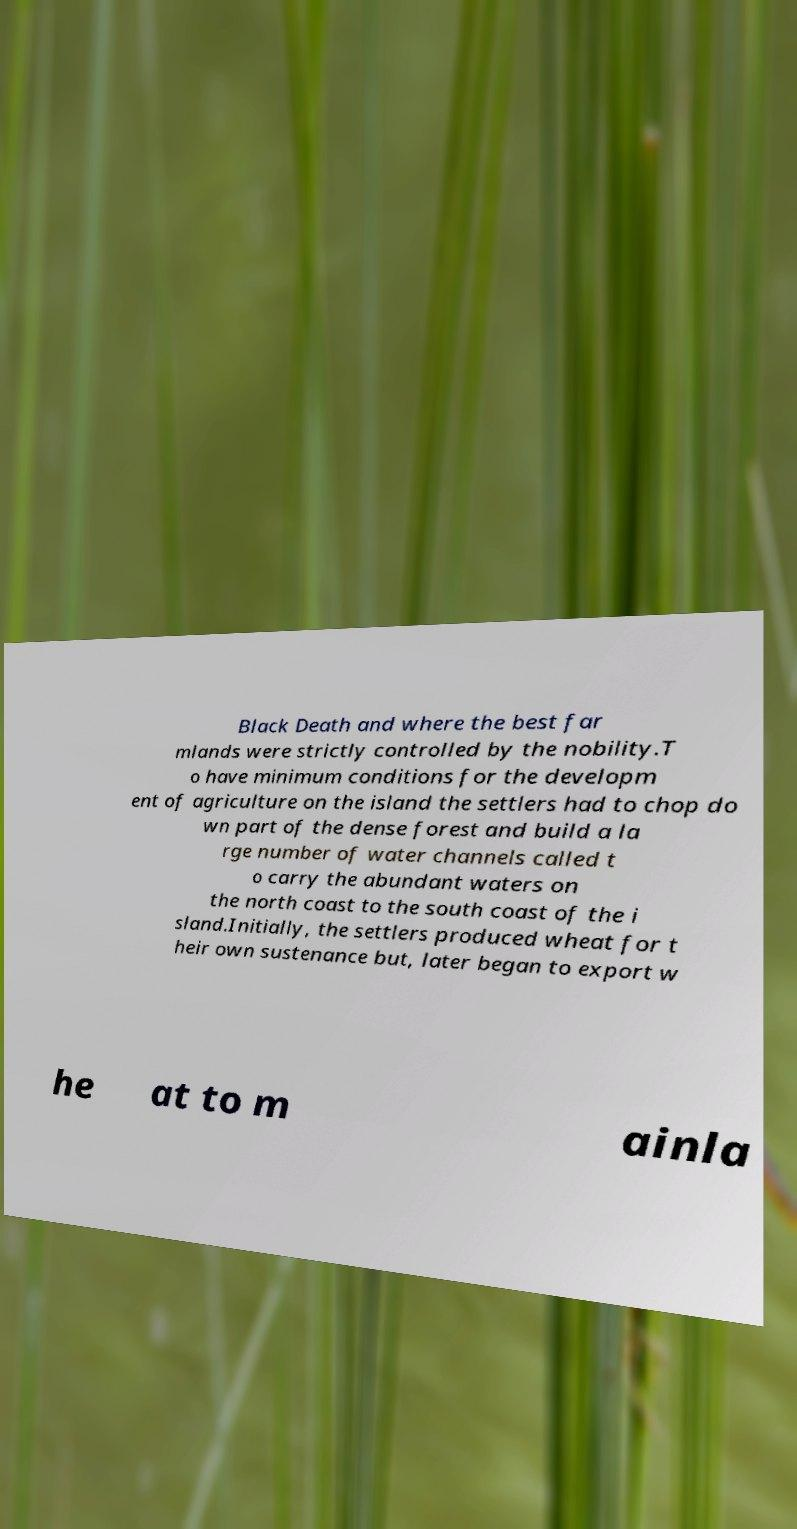Please read and relay the text visible in this image. What does it say? Black Death and where the best far mlands were strictly controlled by the nobility.T o have minimum conditions for the developm ent of agriculture on the island the settlers had to chop do wn part of the dense forest and build a la rge number of water channels called t o carry the abundant waters on the north coast to the south coast of the i sland.Initially, the settlers produced wheat for t heir own sustenance but, later began to export w he at to m ainla 